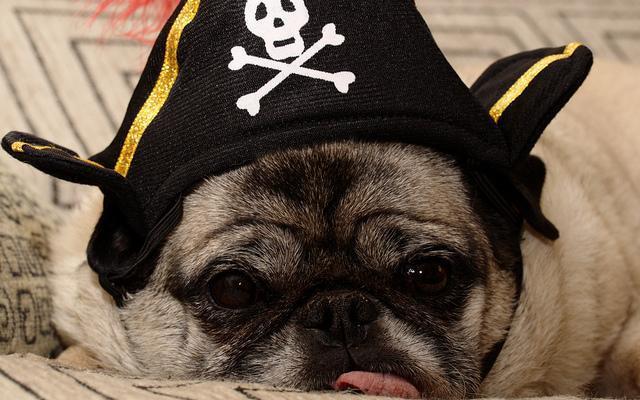How many people are playing wii?
Give a very brief answer. 0. 